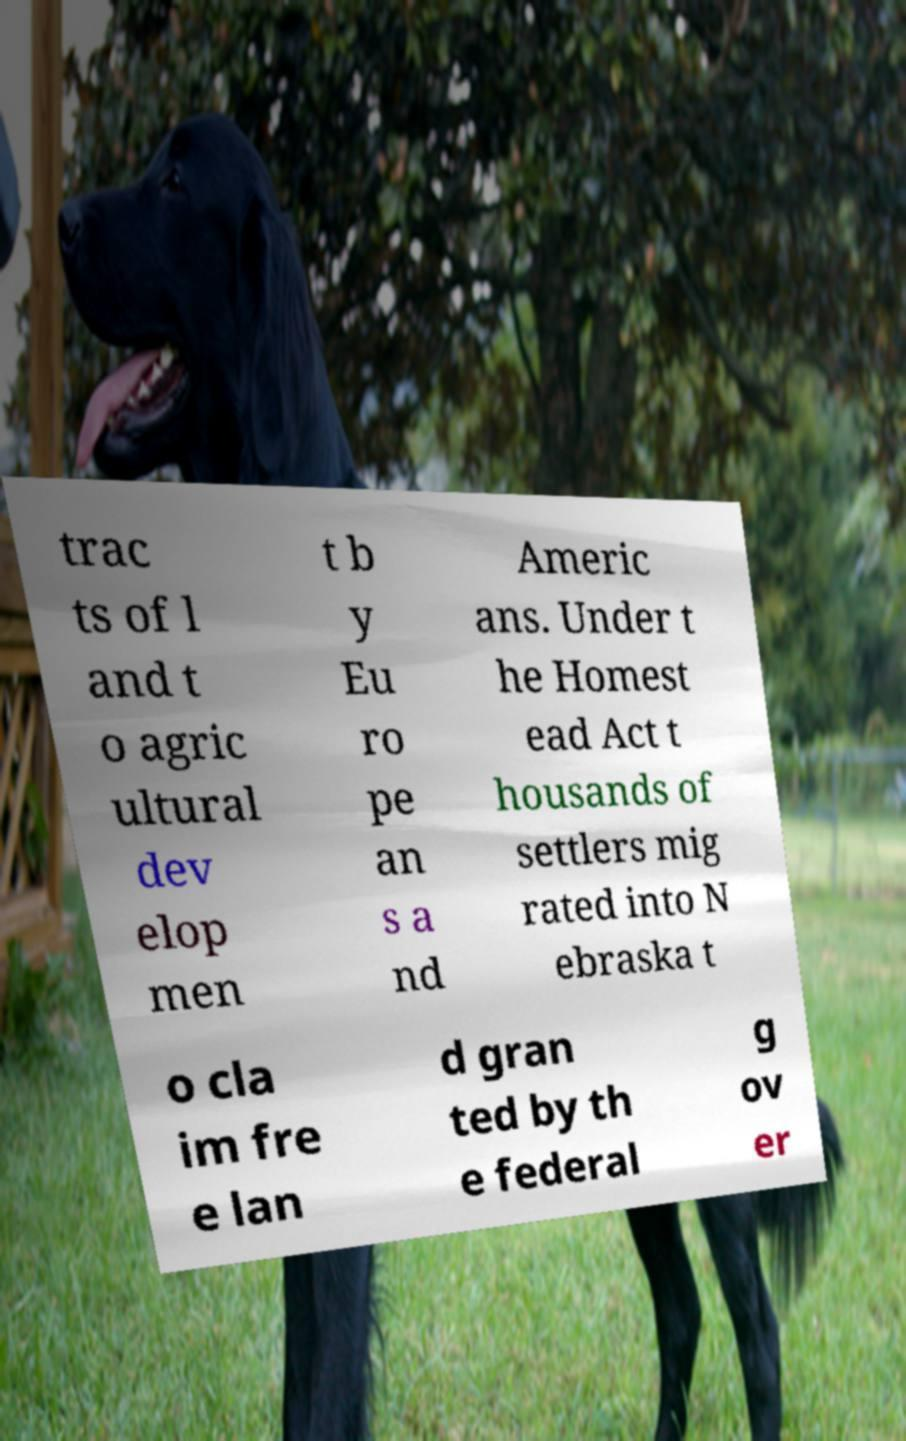Please read and relay the text visible in this image. What does it say? trac ts of l and t o agric ultural dev elop men t b y Eu ro pe an s a nd Americ ans. Under t he Homest ead Act t housands of settlers mig rated into N ebraska t o cla im fre e lan d gran ted by th e federal g ov er 